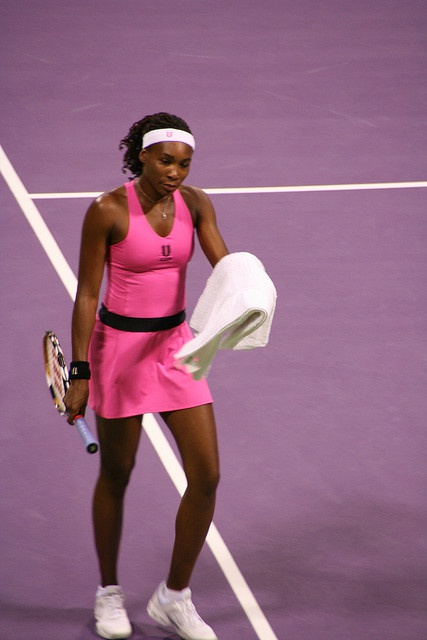Describe the objects in this image and their specific colors. I can see people in purple, black, maroon, violet, and brown tones and tennis racket in purple, tan, brown, black, and gray tones in this image. 